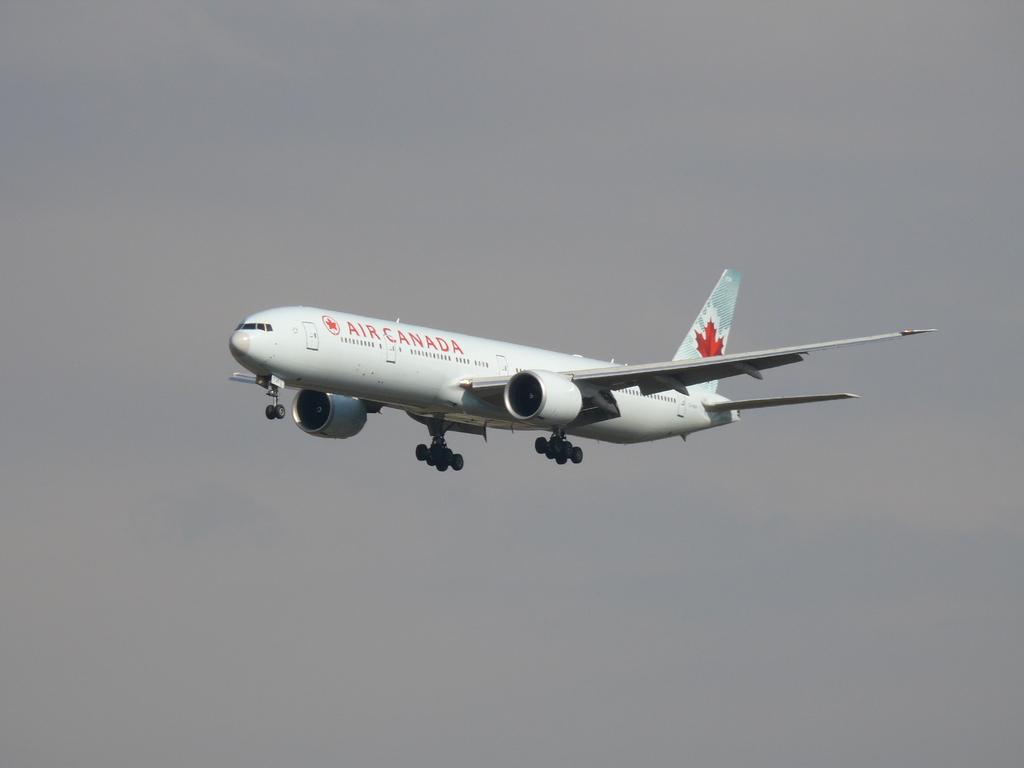What airline brand is this?
Give a very brief answer. Air canada. What country does this plane come from?
Provide a succinct answer. Canada. 